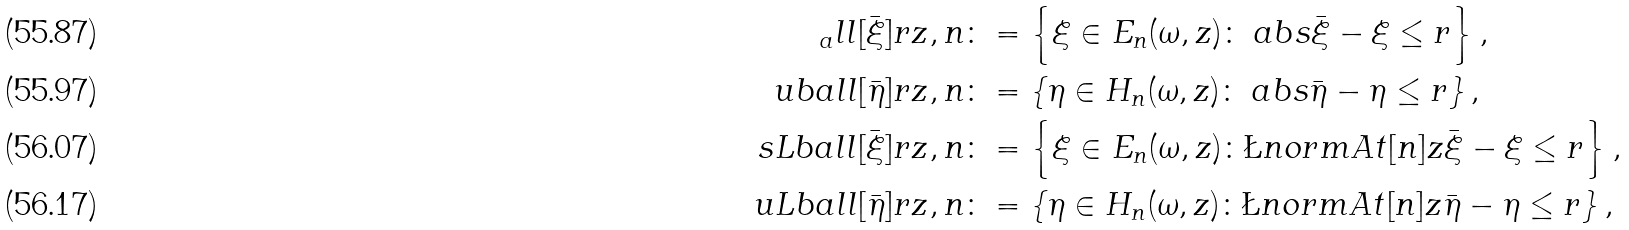<formula> <loc_0><loc_0><loc_500><loc_500>_ { a } l l [ \bar { \xi } ] { r } { z , n } & \colon = \left \{ \xi \in E _ { n } ( \omega , z ) \colon \ a b s { \bar { \xi } - \xi } \leq r \right \} , \\ \ u b a l l [ \bar { \eta } ] { r } { z , n } & \colon = \left \{ \eta \in H _ { n } ( \omega , z ) \colon \ a b s { \bar { \eta } - \eta } \leq r \right \} , \\ \ s L b a l l [ \bar { \xi } ] { r } { z , n } & \colon = \left \{ \xi \in E _ { n } ( \omega , z ) \colon \L n o r m A t [ n ] { z } { \bar { \xi } - \xi } \leq r \right \} , \\ \ u L b a l l [ \bar { \eta } ] { r } { z , n } & \colon = \left \{ \eta \in H _ { n } ( \omega , z ) \colon \L n o r m A t [ n ] { z } { \bar { \eta } - \eta } \leq r \right \} ,</formula> 